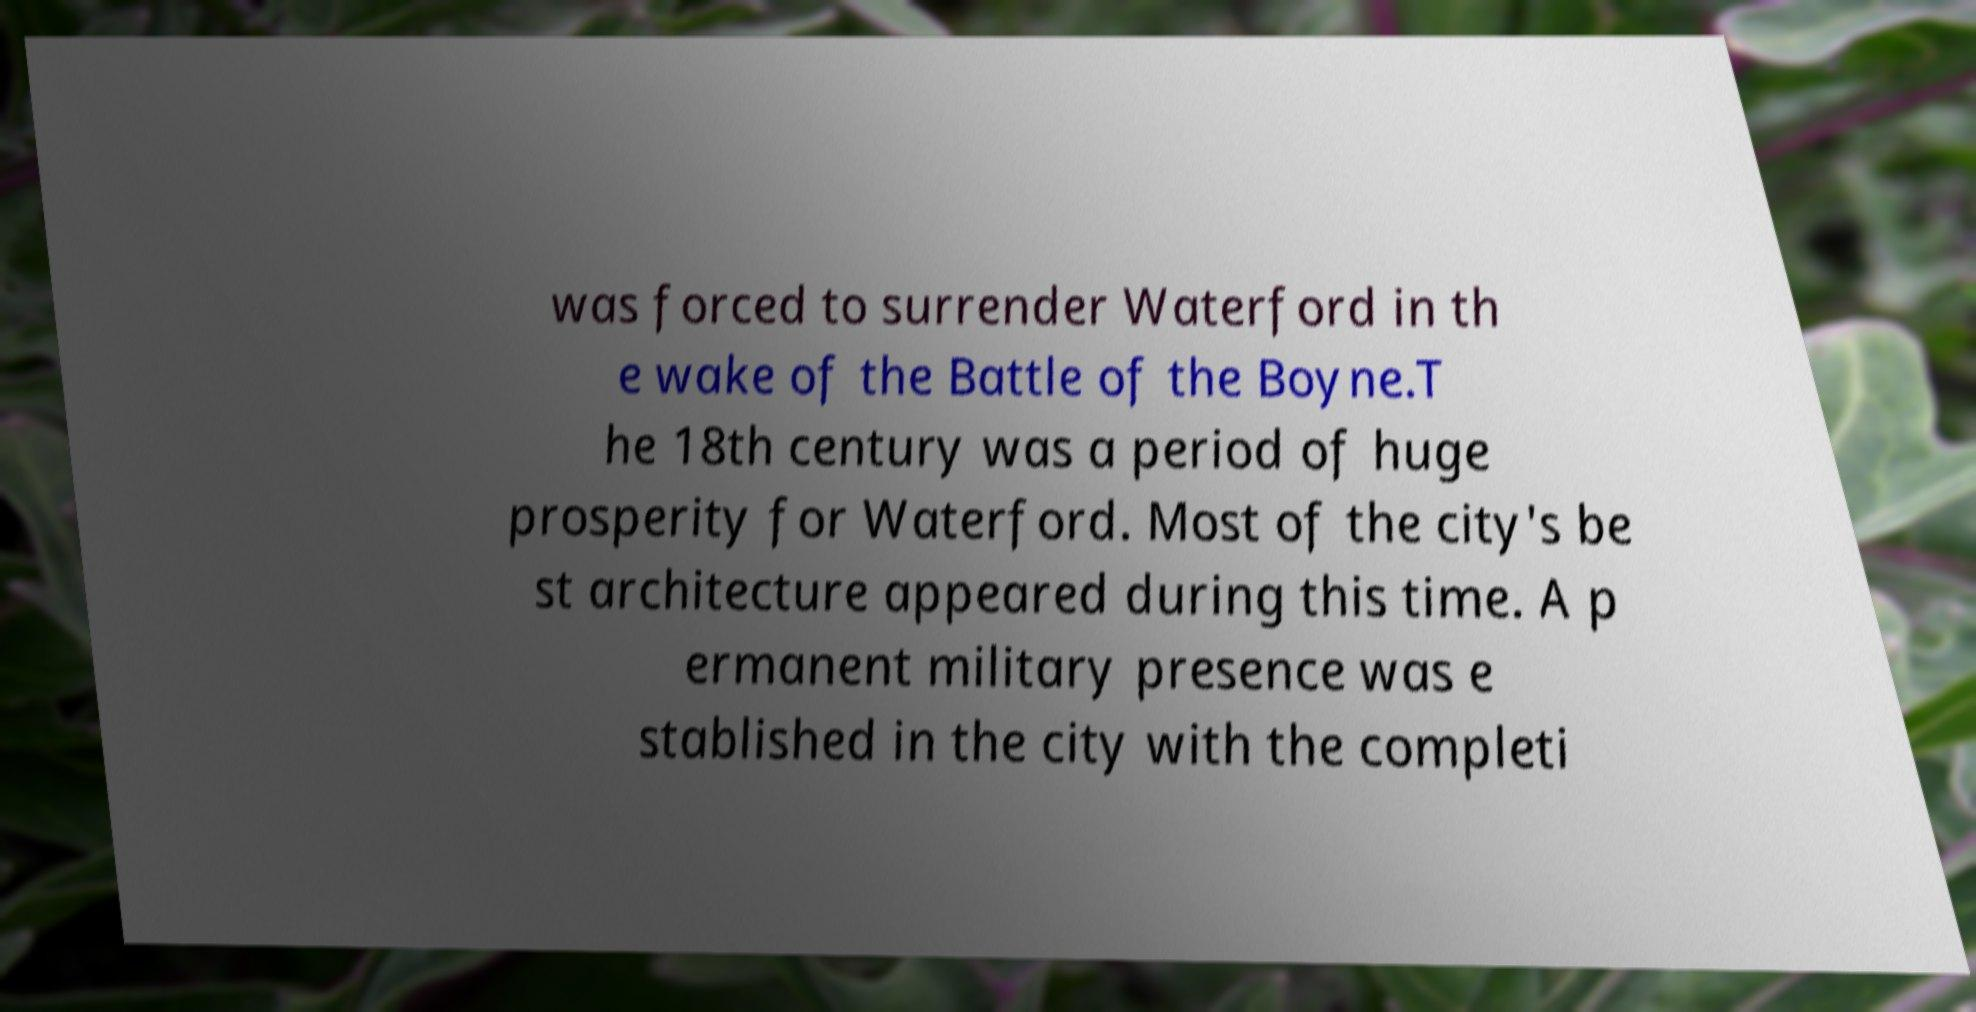What messages or text are displayed in this image? I need them in a readable, typed format. was forced to surrender Waterford in th e wake of the Battle of the Boyne.T he 18th century was a period of huge prosperity for Waterford. Most of the city's be st architecture appeared during this time. A p ermanent military presence was e stablished in the city with the completi 